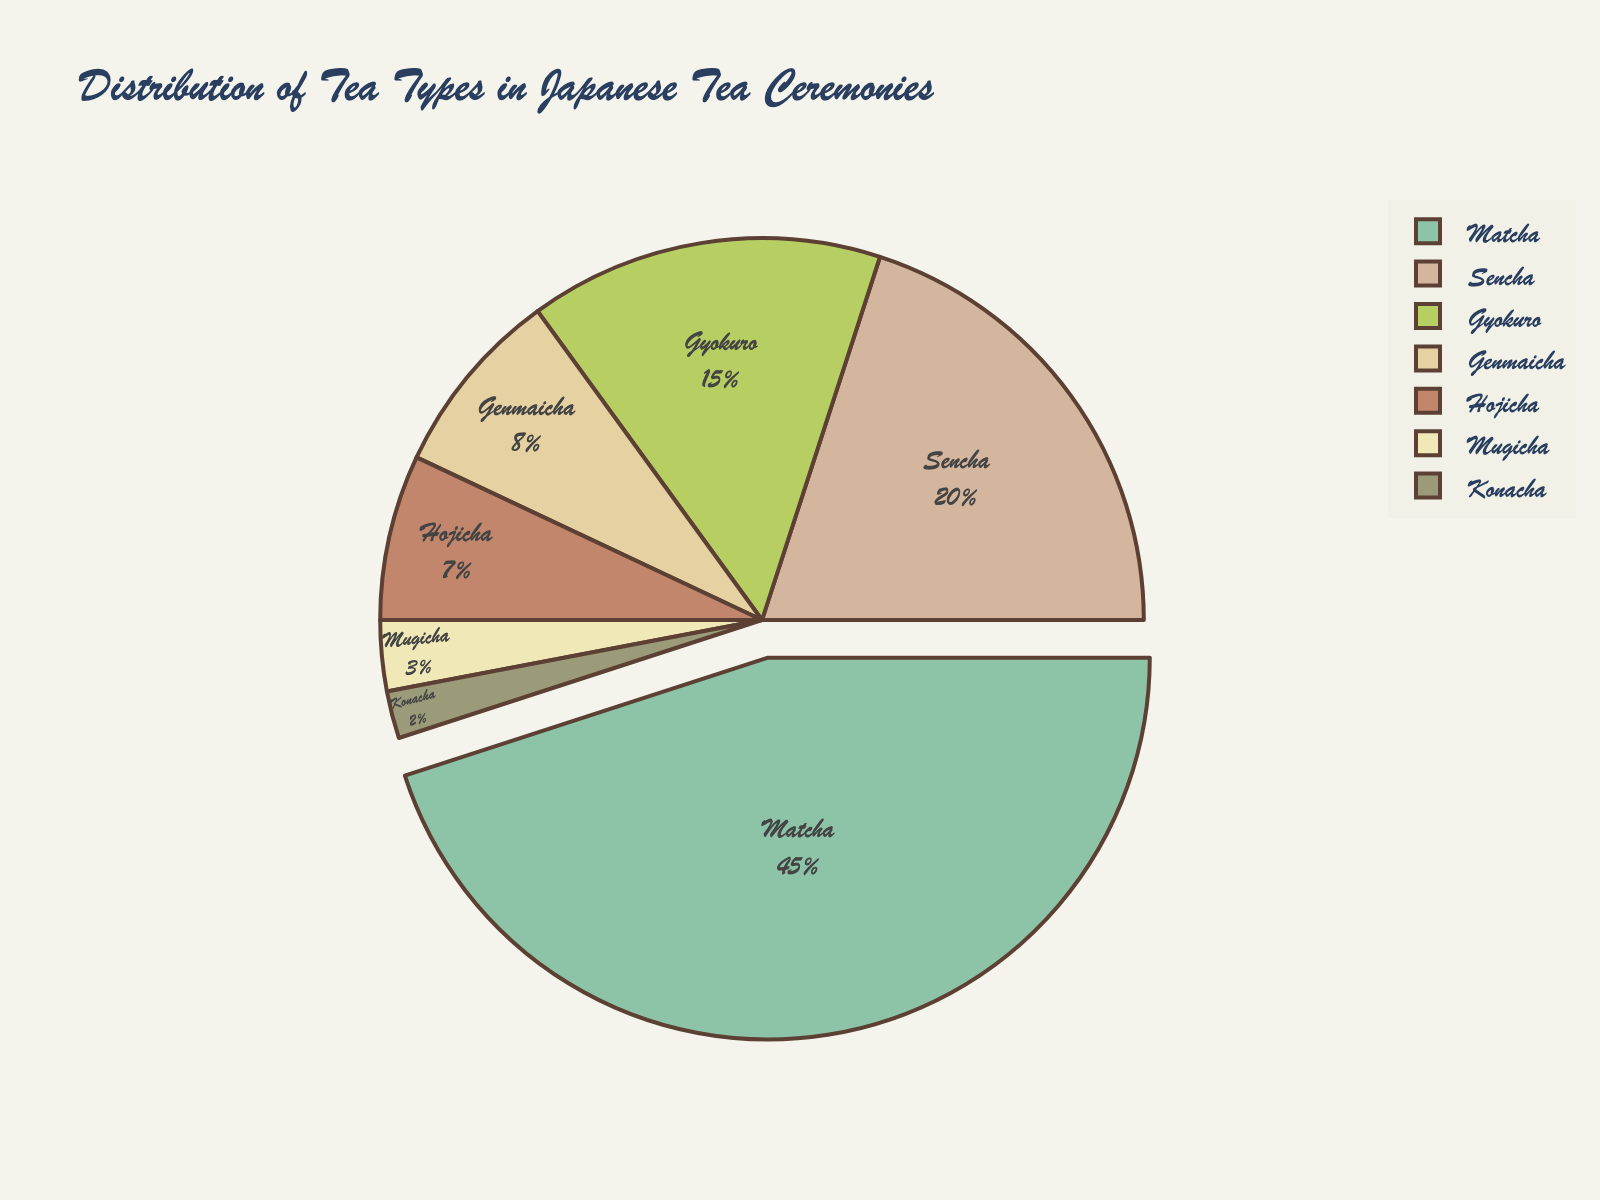Which tea type has the largest percentage in the distribution? The tea type with the largest percentage in the distribution is the section that takes up the most space in the pie chart. This is denoted by the slice pulled out from the chart.
Answer: Matcha What is the combined percentage of Sencha and Gyokuro? Add the percentages of Sencha and Gyokuro together. Sencha has 20% and Gyokuro has 15%, so the combined percentage is 20% + 15% = 35%.
Answer: 35% How does the percentage of Hojicha compare to Genmaicha? By looking at the pie chart, compare the sizes of the Hojicha and Genmaicha slices. Hojicha is 7% while Genmaicha is 8%.
Answer: Genmaicha is higher Which slice appears the smallest, and what is its percentage? Find the smallest section in the pie chart, which is represented by the smallest slice.
Answer: Konacha, 2% What is the total percentage of tea types included in the chart excluding Matcha? Subtract the percentage of Matcha from the total 100%. Matcha is 45%, so 100% - 45% = 55%.
Answer: 55% Compare the sum of percentages of Gyokuro and Hojicha to the percentage of Matcha. Are they greater, less than, or equal? Add the percentages of Gyokuro and Hojicha: 15% + 7% = 22%. Compare this sum to Matcha's percentage which is 45%.
Answer: Less than What colors are used for Sencha and Genmaicha slices? Identify the colors of the slices representing Sencha and Genmaicha from the pie chart.
Answer: Sencha: green, Genmaicha: light brown What percentage of the tea types belong to roasted categories (assume Genmaicha and Hojicha are roasted)? Add the percentages for Genmaicha and Hojicha: 8% + 7% = 15%.
Answer: 15% How does the percentage of Mugicha compare to the percentage of Konacha? Compare the sizes of the Mugicha and Konacha slices. Mugicha is 3%, while Konacha is 2%.
Answer: Mugicha is higher If the title says "Distribution of Tea Types in Japanese Tea Ceremonies," what could be inferred about the cultural relevance of Matcha? Since Matcha takes up the largest portion of the pie chart, it's likely the most significant and frequently used tea type in Japanese tea ceremonies.
Answer: Most significant and frequently used 